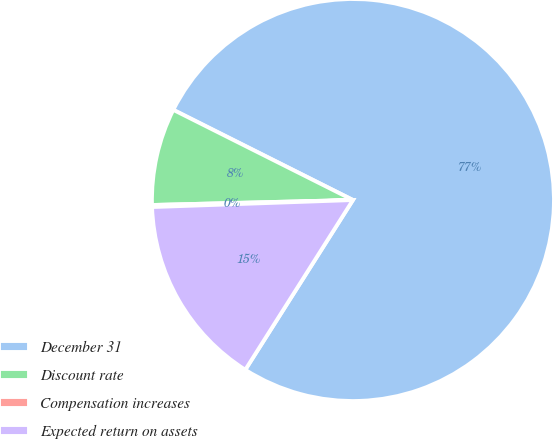Convert chart. <chart><loc_0><loc_0><loc_500><loc_500><pie_chart><fcel>December 31<fcel>Discount rate<fcel>Compensation increases<fcel>Expected return on assets<nl><fcel>76.59%<fcel>7.8%<fcel>0.16%<fcel>15.45%<nl></chart> 